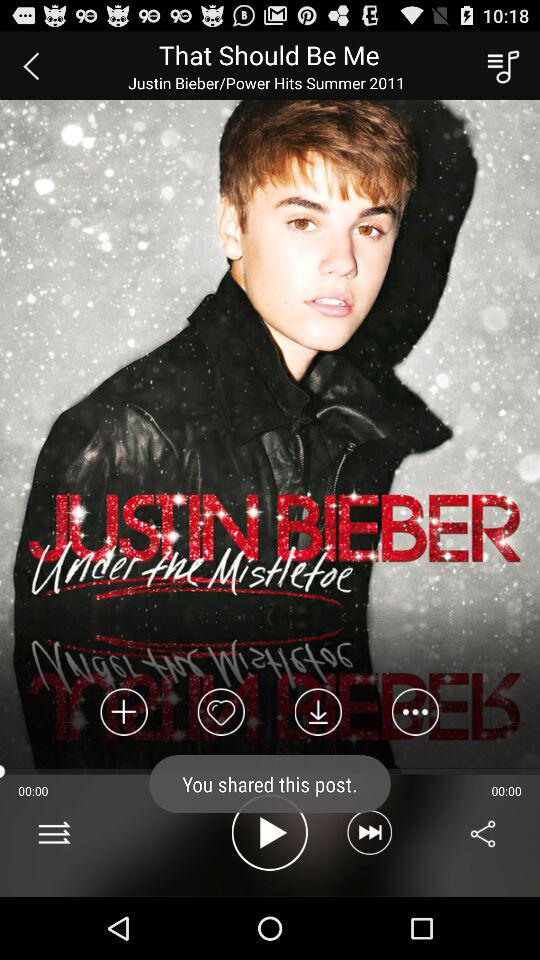Who is the singer of the song "That Should Be Me"? The singer is Justin Bieber. 